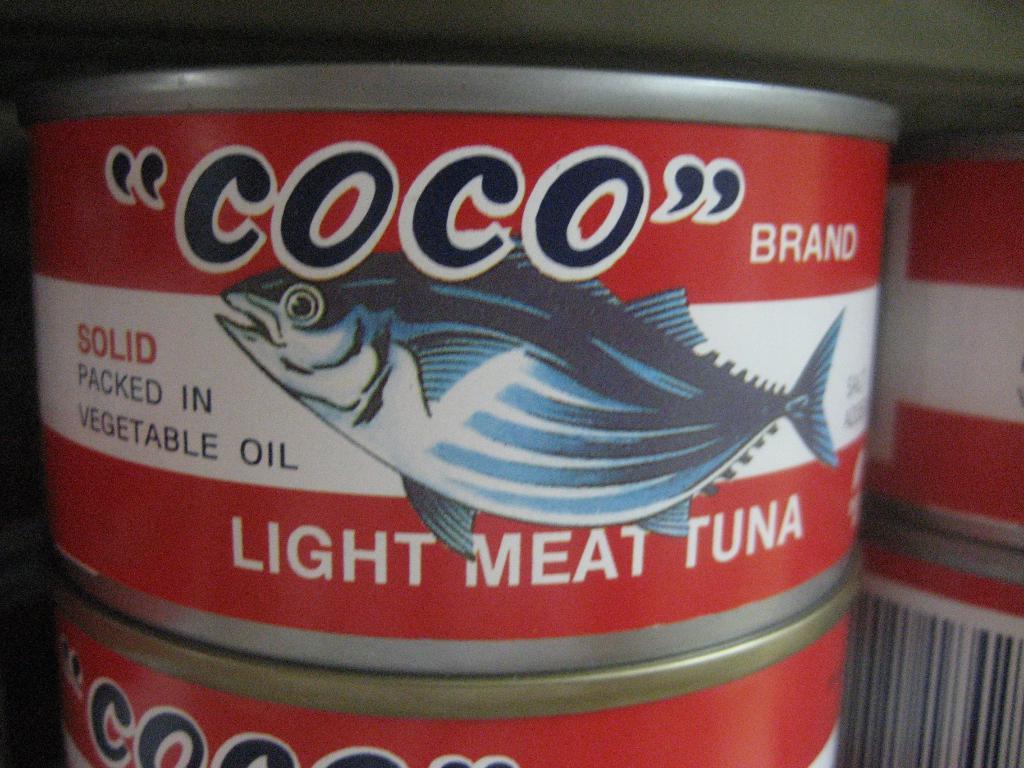What is in this can?
Ensure brevity in your answer.  Light meat tuna. What is the brand?
Give a very brief answer. Coco. 